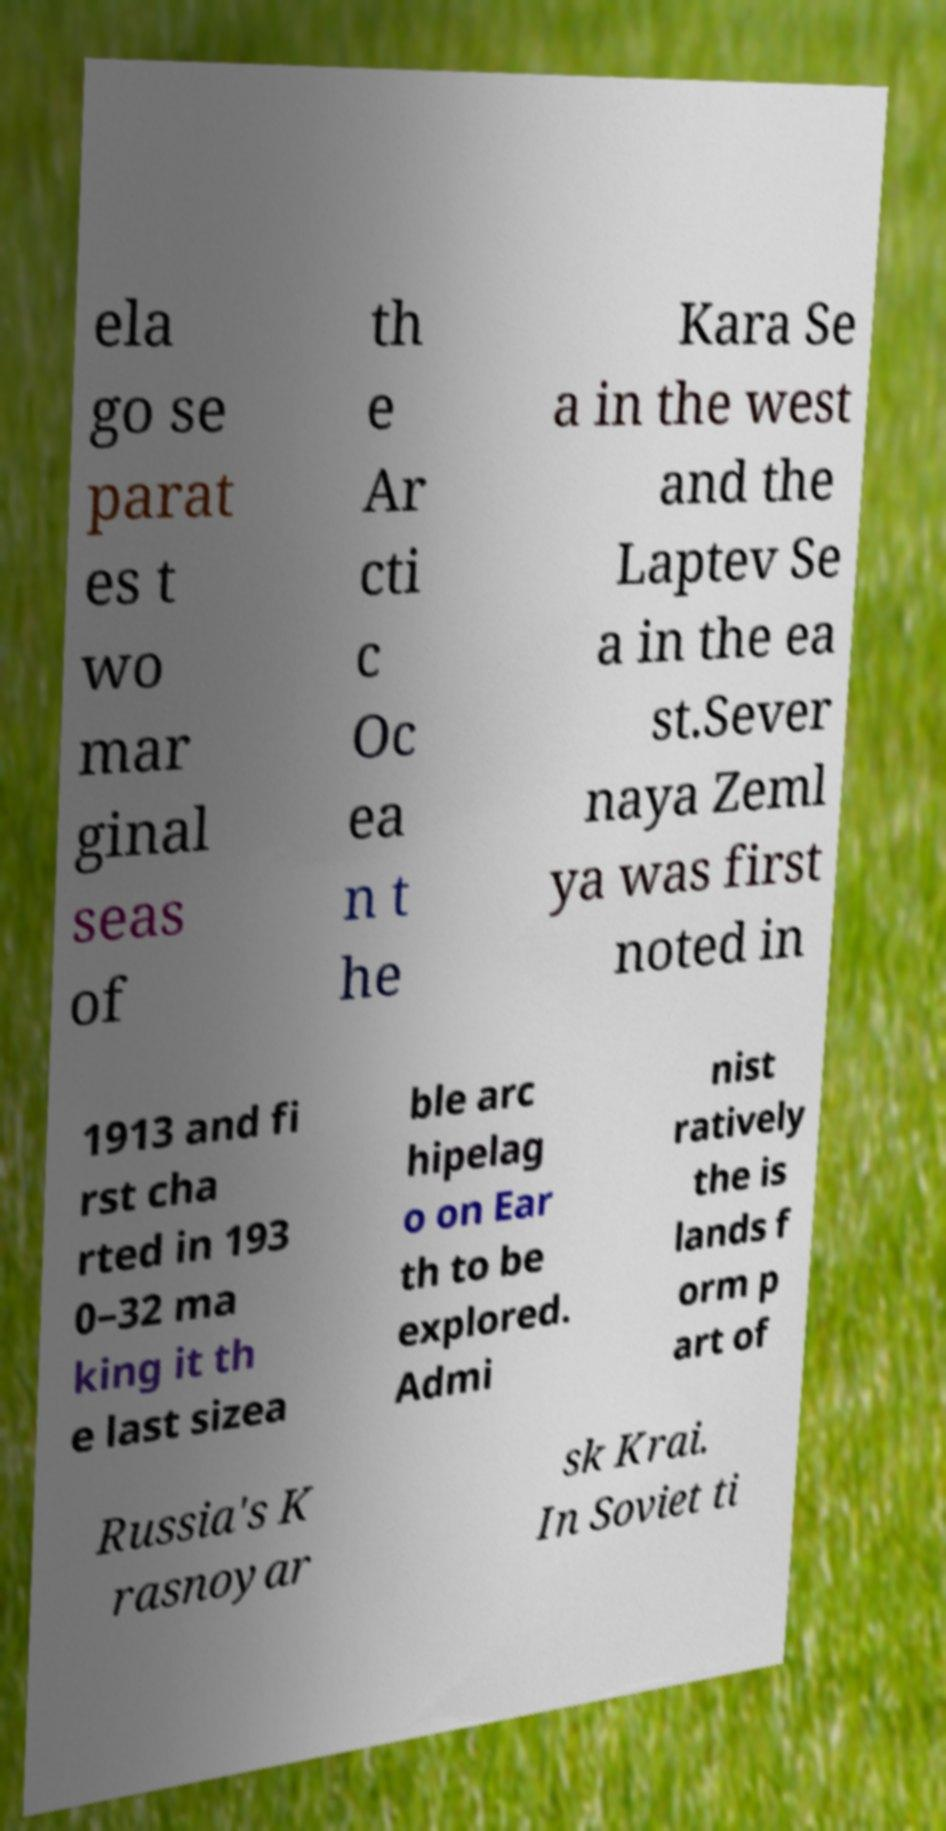Please read and relay the text visible in this image. What does it say? ela go se parat es t wo mar ginal seas of th e Ar cti c Oc ea n t he Kara Se a in the west and the Laptev Se a in the ea st.Sever naya Zeml ya was first noted in 1913 and fi rst cha rted in 193 0–32 ma king it th e last sizea ble arc hipelag o on Ear th to be explored. Admi nist ratively the is lands f orm p art of Russia's K rasnoyar sk Krai. In Soviet ti 